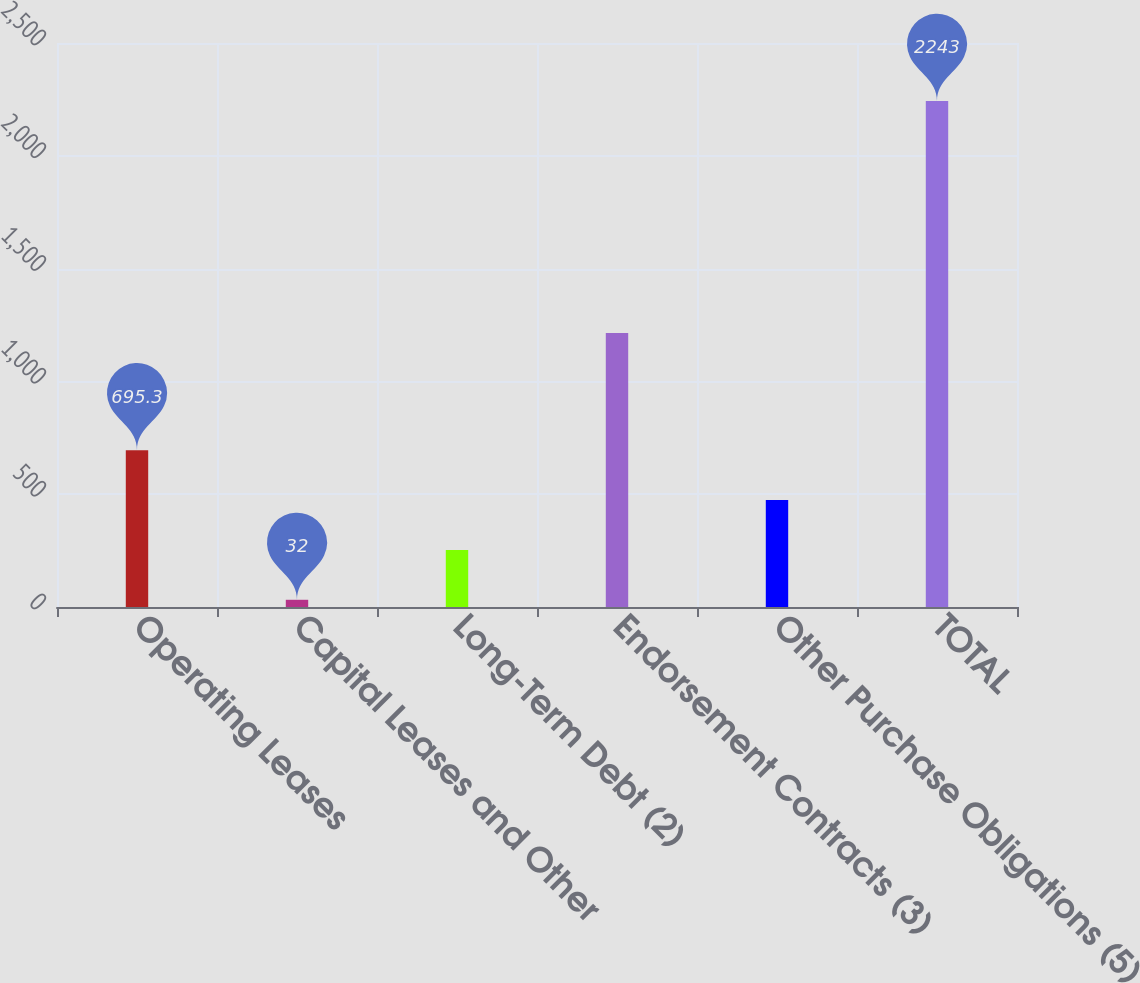Convert chart to OTSL. <chart><loc_0><loc_0><loc_500><loc_500><bar_chart><fcel>Operating Leases<fcel>Capital Leases and Other<fcel>Long-Term Debt (2)<fcel>Endorsement Contracts (3)<fcel>Other Purchase Obligations (5)<fcel>TOTAL<nl><fcel>695.3<fcel>32<fcel>253.1<fcel>1214<fcel>474.2<fcel>2243<nl></chart> 